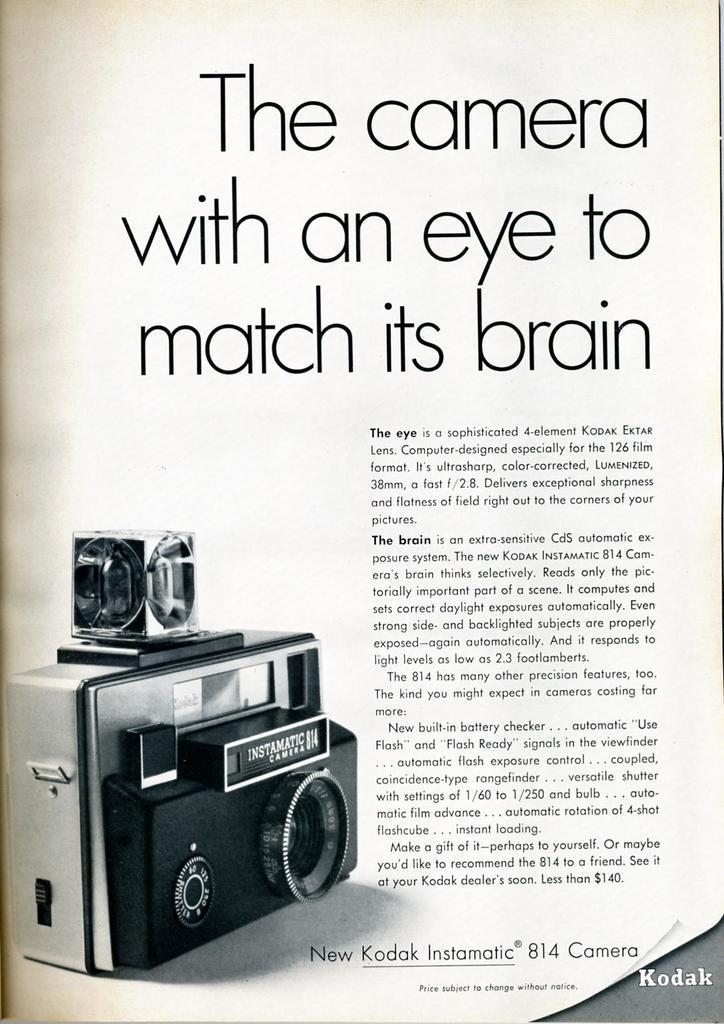Can you describe this image briefly? In this picture I can see a poster, on which there is the image of camera and some text. 